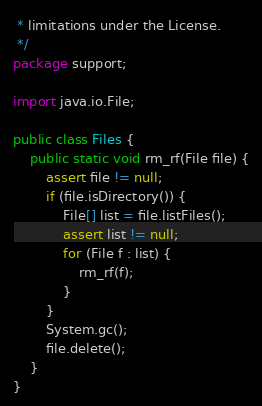<code> <loc_0><loc_0><loc_500><loc_500><_Java_> * limitations under the License.
 */
package support;

import java.io.File;

public class Files {
    public static void rm_rf(File file) {
        assert file != null;
        if (file.isDirectory()) {
            File[] list = file.listFiles();
            assert list != null;
            for (File f : list) {
                rm_rf(f);
            }
        }
        System.gc();
        file.delete();
    }
}
</code> 